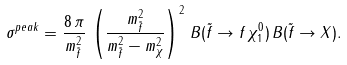<formula> <loc_0><loc_0><loc_500><loc_500>\sigma ^ { p e a k } = \frac { 8 \, \pi } { m _ { \tilde { f } } ^ { 2 } } \, \left ( \frac { m ^ { 2 } _ { \tilde { f } } } { m _ { \tilde { f } } ^ { 2 } - m _ { \chi } ^ { 2 } } \right ) ^ { 2 } \, B ( \tilde { f } \rightarrow f \, \chi ^ { 0 } _ { 1 } ) \, B ( \tilde { f } \rightarrow X ) .</formula> 